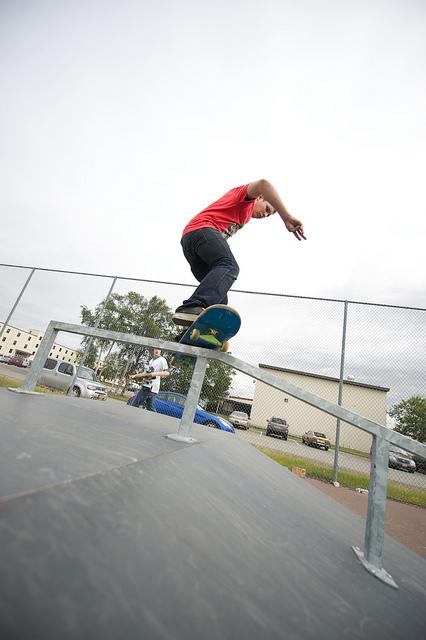Is the sky cloudy?
Give a very brief answer. Yes. What sport is the boy doing?
Quick response, please. Skateboarding. Can you see a blue car?
Write a very short answer. Yes. 